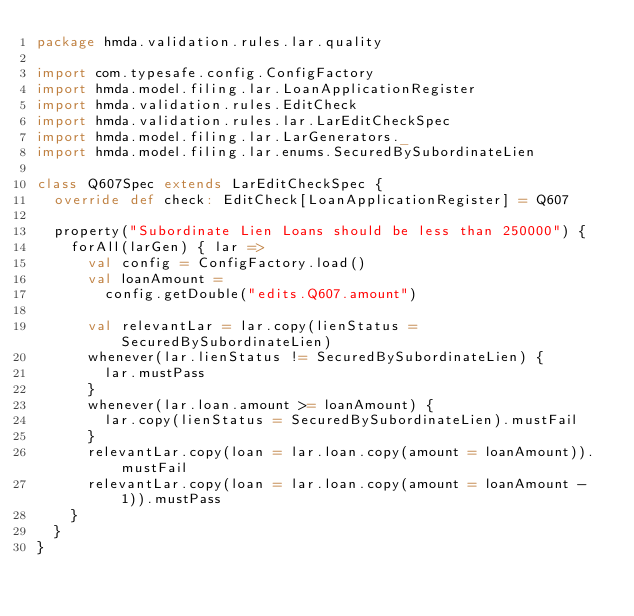Convert code to text. <code><loc_0><loc_0><loc_500><loc_500><_Scala_>package hmda.validation.rules.lar.quality

import com.typesafe.config.ConfigFactory
import hmda.model.filing.lar.LoanApplicationRegister
import hmda.validation.rules.EditCheck
import hmda.validation.rules.lar.LarEditCheckSpec
import hmda.model.filing.lar.LarGenerators._
import hmda.model.filing.lar.enums.SecuredBySubordinateLien

class Q607Spec extends LarEditCheckSpec {
  override def check: EditCheck[LoanApplicationRegister] = Q607

  property("Subordinate Lien Loans should be less than 250000") {
    forAll(larGen) { lar =>
      val config = ConfigFactory.load()
      val loanAmount =
        config.getDouble("edits.Q607.amount")

      val relevantLar = lar.copy(lienStatus = SecuredBySubordinateLien)
      whenever(lar.lienStatus != SecuredBySubordinateLien) {
        lar.mustPass
      }
      whenever(lar.loan.amount >= loanAmount) {
        lar.copy(lienStatus = SecuredBySubordinateLien).mustFail
      }
      relevantLar.copy(loan = lar.loan.copy(amount = loanAmount)).mustFail
      relevantLar.copy(loan = lar.loan.copy(amount = loanAmount - 1)).mustPass
    }
  }
}
</code> 